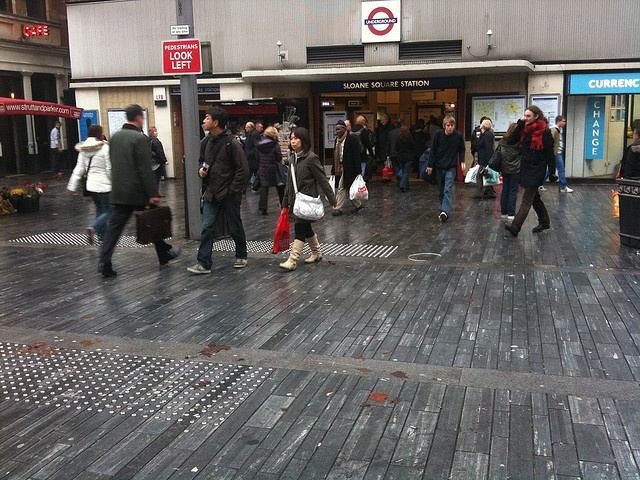Describe the objects in this image and their specific colors. I can see people in black, gray, maroon, and ivory tones, people in black, gray, and maroon tones, people in black, gray, maroon, and darkgray tones, people in black, maroon, gray, and brown tones, and people in black, white, gray, and darkgray tones in this image. 